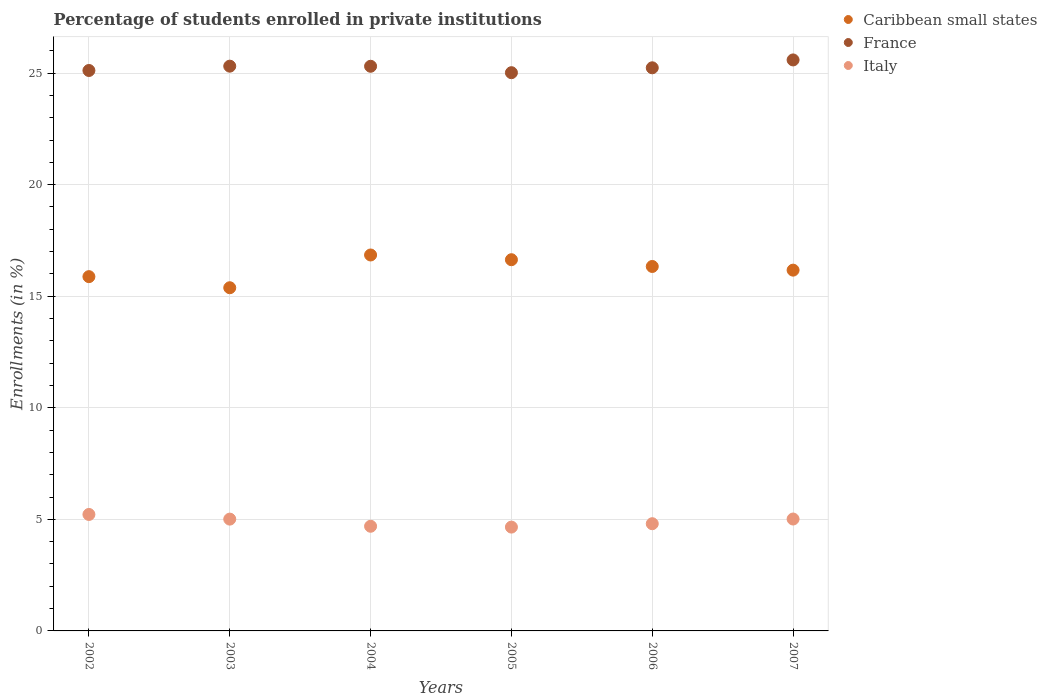Is the number of dotlines equal to the number of legend labels?
Make the answer very short. Yes. What is the percentage of trained teachers in France in 2006?
Provide a short and direct response. 25.24. Across all years, what is the maximum percentage of trained teachers in Italy?
Provide a succinct answer. 5.22. Across all years, what is the minimum percentage of trained teachers in Italy?
Offer a terse response. 4.65. In which year was the percentage of trained teachers in Caribbean small states minimum?
Keep it short and to the point. 2003. What is the total percentage of trained teachers in France in the graph?
Give a very brief answer. 151.57. What is the difference between the percentage of trained teachers in Caribbean small states in 2006 and that in 2007?
Keep it short and to the point. 0.16. What is the difference between the percentage of trained teachers in Italy in 2005 and the percentage of trained teachers in Caribbean small states in 2007?
Make the answer very short. -11.52. What is the average percentage of trained teachers in Italy per year?
Provide a succinct answer. 4.9. In the year 2005, what is the difference between the percentage of trained teachers in Caribbean small states and percentage of trained teachers in Italy?
Offer a very short reply. 11.98. What is the ratio of the percentage of trained teachers in Italy in 2003 to that in 2006?
Give a very brief answer. 1.04. Is the percentage of trained teachers in France in 2002 less than that in 2005?
Your answer should be compact. No. What is the difference between the highest and the second highest percentage of trained teachers in Italy?
Offer a terse response. 0.21. What is the difference between the highest and the lowest percentage of trained teachers in France?
Your answer should be very brief. 0.57. How many dotlines are there?
Offer a terse response. 3. Are the values on the major ticks of Y-axis written in scientific E-notation?
Give a very brief answer. No. Does the graph contain any zero values?
Give a very brief answer. No. How many legend labels are there?
Offer a terse response. 3. How are the legend labels stacked?
Provide a short and direct response. Vertical. What is the title of the graph?
Provide a succinct answer. Percentage of students enrolled in private institutions. Does "Libya" appear as one of the legend labels in the graph?
Provide a succinct answer. No. What is the label or title of the Y-axis?
Provide a short and direct response. Enrollments (in %). What is the Enrollments (in %) of Caribbean small states in 2002?
Provide a short and direct response. 15.88. What is the Enrollments (in %) in France in 2002?
Provide a succinct answer. 25.12. What is the Enrollments (in %) in Italy in 2002?
Offer a very short reply. 5.22. What is the Enrollments (in %) in Caribbean small states in 2003?
Keep it short and to the point. 15.38. What is the Enrollments (in %) of France in 2003?
Provide a short and direct response. 25.31. What is the Enrollments (in %) of Italy in 2003?
Your response must be concise. 5.01. What is the Enrollments (in %) in Caribbean small states in 2004?
Keep it short and to the point. 16.85. What is the Enrollments (in %) in France in 2004?
Offer a very short reply. 25.3. What is the Enrollments (in %) of Italy in 2004?
Provide a short and direct response. 4.69. What is the Enrollments (in %) in Caribbean small states in 2005?
Ensure brevity in your answer.  16.64. What is the Enrollments (in %) in France in 2005?
Your answer should be compact. 25.02. What is the Enrollments (in %) in Italy in 2005?
Make the answer very short. 4.65. What is the Enrollments (in %) of Caribbean small states in 2006?
Offer a very short reply. 16.33. What is the Enrollments (in %) of France in 2006?
Your answer should be very brief. 25.24. What is the Enrollments (in %) of Italy in 2006?
Your answer should be compact. 4.8. What is the Enrollments (in %) in Caribbean small states in 2007?
Offer a terse response. 16.17. What is the Enrollments (in %) in France in 2007?
Give a very brief answer. 25.59. What is the Enrollments (in %) of Italy in 2007?
Make the answer very short. 5.01. Across all years, what is the maximum Enrollments (in %) of Caribbean small states?
Your answer should be very brief. 16.85. Across all years, what is the maximum Enrollments (in %) in France?
Provide a succinct answer. 25.59. Across all years, what is the maximum Enrollments (in %) in Italy?
Offer a very short reply. 5.22. Across all years, what is the minimum Enrollments (in %) in Caribbean small states?
Offer a very short reply. 15.38. Across all years, what is the minimum Enrollments (in %) in France?
Keep it short and to the point. 25.02. Across all years, what is the minimum Enrollments (in %) in Italy?
Ensure brevity in your answer.  4.65. What is the total Enrollments (in %) in Caribbean small states in the graph?
Make the answer very short. 97.24. What is the total Enrollments (in %) of France in the graph?
Your response must be concise. 151.57. What is the total Enrollments (in %) of Italy in the graph?
Your response must be concise. 29.39. What is the difference between the Enrollments (in %) of Caribbean small states in 2002 and that in 2003?
Your answer should be compact. 0.5. What is the difference between the Enrollments (in %) in France in 2002 and that in 2003?
Your answer should be very brief. -0.19. What is the difference between the Enrollments (in %) of Italy in 2002 and that in 2003?
Offer a very short reply. 0.21. What is the difference between the Enrollments (in %) of Caribbean small states in 2002 and that in 2004?
Keep it short and to the point. -0.97. What is the difference between the Enrollments (in %) in France in 2002 and that in 2004?
Give a very brief answer. -0.19. What is the difference between the Enrollments (in %) in Italy in 2002 and that in 2004?
Keep it short and to the point. 0.53. What is the difference between the Enrollments (in %) in Caribbean small states in 2002 and that in 2005?
Offer a terse response. -0.76. What is the difference between the Enrollments (in %) of France in 2002 and that in 2005?
Your answer should be very brief. 0.1. What is the difference between the Enrollments (in %) of Italy in 2002 and that in 2005?
Provide a short and direct response. 0.57. What is the difference between the Enrollments (in %) in Caribbean small states in 2002 and that in 2006?
Ensure brevity in your answer.  -0.46. What is the difference between the Enrollments (in %) in France in 2002 and that in 2006?
Provide a short and direct response. -0.12. What is the difference between the Enrollments (in %) of Italy in 2002 and that in 2006?
Provide a short and direct response. 0.41. What is the difference between the Enrollments (in %) in Caribbean small states in 2002 and that in 2007?
Provide a succinct answer. -0.29. What is the difference between the Enrollments (in %) in France in 2002 and that in 2007?
Offer a terse response. -0.47. What is the difference between the Enrollments (in %) of Italy in 2002 and that in 2007?
Give a very brief answer. 0.21. What is the difference between the Enrollments (in %) in Caribbean small states in 2003 and that in 2004?
Ensure brevity in your answer.  -1.47. What is the difference between the Enrollments (in %) of France in 2003 and that in 2004?
Your answer should be compact. 0. What is the difference between the Enrollments (in %) of Italy in 2003 and that in 2004?
Offer a very short reply. 0.32. What is the difference between the Enrollments (in %) in Caribbean small states in 2003 and that in 2005?
Your answer should be very brief. -1.26. What is the difference between the Enrollments (in %) of France in 2003 and that in 2005?
Keep it short and to the point. 0.29. What is the difference between the Enrollments (in %) of Italy in 2003 and that in 2005?
Provide a succinct answer. 0.36. What is the difference between the Enrollments (in %) of Caribbean small states in 2003 and that in 2006?
Offer a terse response. -0.95. What is the difference between the Enrollments (in %) of France in 2003 and that in 2006?
Provide a short and direct response. 0.07. What is the difference between the Enrollments (in %) of Italy in 2003 and that in 2006?
Keep it short and to the point. 0.21. What is the difference between the Enrollments (in %) in Caribbean small states in 2003 and that in 2007?
Keep it short and to the point. -0.79. What is the difference between the Enrollments (in %) in France in 2003 and that in 2007?
Your answer should be very brief. -0.28. What is the difference between the Enrollments (in %) of Italy in 2003 and that in 2007?
Your answer should be very brief. -0. What is the difference between the Enrollments (in %) of Caribbean small states in 2004 and that in 2005?
Your answer should be compact. 0.21. What is the difference between the Enrollments (in %) of France in 2004 and that in 2005?
Provide a succinct answer. 0.29. What is the difference between the Enrollments (in %) in Italy in 2004 and that in 2005?
Offer a very short reply. 0.04. What is the difference between the Enrollments (in %) of Caribbean small states in 2004 and that in 2006?
Your answer should be very brief. 0.51. What is the difference between the Enrollments (in %) of France in 2004 and that in 2006?
Provide a short and direct response. 0.07. What is the difference between the Enrollments (in %) of Italy in 2004 and that in 2006?
Your answer should be very brief. -0.11. What is the difference between the Enrollments (in %) in Caribbean small states in 2004 and that in 2007?
Give a very brief answer. 0.68. What is the difference between the Enrollments (in %) in France in 2004 and that in 2007?
Offer a terse response. -0.28. What is the difference between the Enrollments (in %) in Italy in 2004 and that in 2007?
Make the answer very short. -0.32. What is the difference between the Enrollments (in %) in Caribbean small states in 2005 and that in 2006?
Offer a very short reply. 0.3. What is the difference between the Enrollments (in %) in France in 2005 and that in 2006?
Your answer should be very brief. -0.22. What is the difference between the Enrollments (in %) in Italy in 2005 and that in 2006?
Provide a succinct answer. -0.15. What is the difference between the Enrollments (in %) in Caribbean small states in 2005 and that in 2007?
Your answer should be compact. 0.47. What is the difference between the Enrollments (in %) of France in 2005 and that in 2007?
Make the answer very short. -0.57. What is the difference between the Enrollments (in %) in Italy in 2005 and that in 2007?
Provide a succinct answer. -0.36. What is the difference between the Enrollments (in %) in Caribbean small states in 2006 and that in 2007?
Ensure brevity in your answer.  0.16. What is the difference between the Enrollments (in %) in France in 2006 and that in 2007?
Ensure brevity in your answer.  -0.35. What is the difference between the Enrollments (in %) of Italy in 2006 and that in 2007?
Your answer should be compact. -0.21. What is the difference between the Enrollments (in %) in Caribbean small states in 2002 and the Enrollments (in %) in France in 2003?
Make the answer very short. -9.43. What is the difference between the Enrollments (in %) of Caribbean small states in 2002 and the Enrollments (in %) of Italy in 2003?
Provide a succinct answer. 10.87. What is the difference between the Enrollments (in %) in France in 2002 and the Enrollments (in %) in Italy in 2003?
Keep it short and to the point. 20.11. What is the difference between the Enrollments (in %) of Caribbean small states in 2002 and the Enrollments (in %) of France in 2004?
Your answer should be compact. -9.43. What is the difference between the Enrollments (in %) in Caribbean small states in 2002 and the Enrollments (in %) in Italy in 2004?
Your response must be concise. 11.19. What is the difference between the Enrollments (in %) of France in 2002 and the Enrollments (in %) of Italy in 2004?
Your response must be concise. 20.43. What is the difference between the Enrollments (in %) in Caribbean small states in 2002 and the Enrollments (in %) in France in 2005?
Your answer should be compact. -9.14. What is the difference between the Enrollments (in %) of Caribbean small states in 2002 and the Enrollments (in %) of Italy in 2005?
Offer a terse response. 11.22. What is the difference between the Enrollments (in %) in France in 2002 and the Enrollments (in %) in Italy in 2005?
Your answer should be very brief. 20.46. What is the difference between the Enrollments (in %) of Caribbean small states in 2002 and the Enrollments (in %) of France in 2006?
Offer a terse response. -9.36. What is the difference between the Enrollments (in %) in Caribbean small states in 2002 and the Enrollments (in %) in Italy in 2006?
Provide a succinct answer. 11.07. What is the difference between the Enrollments (in %) in France in 2002 and the Enrollments (in %) in Italy in 2006?
Provide a short and direct response. 20.31. What is the difference between the Enrollments (in %) in Caribbean small states in 2002 and the Enrollments (in %) in France in 2007?
Make the answer very short. -9.71. What is the difference between the Enrollments (in %) of Caribbean small states in 2002 and the Enrollments (in %) of Italy in 2007?
Provide a succinct answer. 10.86. What is the difference between the Enrollments (in %) of France in 2002 and the Enrollments (in %) of Italy in 2007?
Ensure brevity in your answer.  20.1. What is the difference between the Enrollments (in %) of Caribbean small states in 2003 and the Enrollments (in %) of France in 2004?
Keep it short and to the point. -9.92. What is the difference between the Enrollments (in %) of Caribbean small states in 2003 and the Enrollments (in %) of Italy in 2004?
Offer a terse response. 10.69. What is the difference between the Enrollments (in %) of France in 2003 and the Enrollments (in %) of Italy in 2004?
Your response must be concise. 20.62. What is the difference between the Enrollments (in %) of Caribbean small states in 2003 and the Enrollments (in %) of France in 2005?
Offer a terse response. -9.64. What is the difference between the Enrollments (in %) in Caribbean small states in 2003 and the Enrollments (in %) in Italy in 2005?
Keep it short and to the point. 10.73. What is the difference between the Enrollments (in %) in France in 2003 and the Enrollments (in %) in Italy in 2005?
Offer a terse response. 20.66. What is the difference between the Enrollments (in %) of Caribbean small states in 2003 and the Enrollments (in %) of France in 2006?
Offer a very short reply. -9.86. What is the difference between the Enrollments (in %) of Caribbean small states in 2003 and the Enrollments (in %) of Italy in 2006?
Provide a succinct answer. 10.57. What is the difference between the Enrollments (in %) of France in 2003 and the Enrollments (in %) of Italy in 2006?
Your answer should be very brief. 20.5. What is the difference between the Enrollments (in %) in Caribbean small states in 2003 and the Enrollments (in %) in France in 2007?
Give a very brief answer. -10.21. What is the difference between the Enrollments (in %) of Caribbean small states in 2003 and the Enrollments (in %) of Italy in 2007?
Your answer should be very brief. 10.37. What is the difference between the Enrollments (in %) in France in 2003 and the Enrollments (in %) in Italy in 2007?
Your answer should be very brief. 20.29. What is the difference between the Enrollments (in %) in Caribbean small states in 2004 and the Enrollments (in %) in France in 2005?
Make the answer very short. -8.17. What is the difference between the Enrollments (in %) in Caribbean small states in 2004 and the Enrollments (in %) in Italy in 2005?
Your answer should be very brief. 12.19. What is the difference between the Enrollments (in %) in France in 2004 and the Enrollments (in %) in Italy in 2005?
Give a very brief answer. 20.65. What is the difference between the Enrollments (in %) in Caribbean small states in 2004 and the Enrollments (in %) in France in 2006?
Make the answer very short. -8.39. What is the difference between the Enrollments (in %) of Caribbean small states in 2004 and the Enrollments (in %) of Italy in 2006?
Offer a very short reply. 12.04. What is the difference between the Enrollments (in %) of France in 2004 and the Enrollments (in %) of Italy in 2006?
Give a very brief answer. 20.5. What is the difference between the Enrollments (in %) in Caribbean small states in 2004 and the Enrollments (in %) in France in 2007?
Keep it short and to the point. -8.74. What is the difference between the Enrollments (in %) of Caribbean small states in 2004 and the Enrollments (in %) of Italy in 2007?
Give a very brief answer. 11.83. What is the difference between the Enrollments (in %) of France in 2004 and the Enrollments (in %) of Italy in 2007?
Give a very brief answer. 20.29. What is the difference between the Enrollments (in %) in Caribbean small states in 2005 and the Enrollments (in %) in France in 2006?
Your response must be concise. -8.6. What is the difference between the Enrollments (in %) in Caribbean small states in 2005 and the Enrollments (in %) in Italy in 2006?
Offer a very short reply. 11.83. What is the difference between the Enrollments (in %) in France in 2005 and the Enrollments (in %) in Italy in 2006?
Offer a terse response. 20.21. What is the difference between the Enrollments (in %) in Caribbean small states in 2005 and the Enrollments (in %) in France in 2007?
Your answer should be compact. -8.95. What is the difference between the Enrollments (in %) in Caribbean small states in 2005 and the Enrollments (in %) in Italy in 2007?
Provide a short and direct response. 11.62. What is the difference between the Enrollments (in %) of France in 2005 and the Enrollments (in %) of Italy in 2007?
Ensure brevity in your answer.  20. What is the difference between the Enrollments (in %) in Caribbean small states in 2006 and the Enrollments (in %) in France in 2007?
Provide a short and direct response. -9.26. What is the difference between the Enrollments (in %) of Caribbean small states in 2006 and the Enrollments (in %) of Italy in 2007?
Offer a very short reply. 11.32. What is the difference between the Enrollments (in %) of France in 2006 and the Enrollments (in %) of Italy in 2007?
Your response must be concise. 20.22. What is the average Enrollments (in %) of Caribbean small states per year?
Provide a succinct answer. 16.21. What is the average Enrollments (in %) in France per year?
Give a very brief answer. 25.26. What is the average Enrollments (in %) in Italy per year?
Your response must be concise. 4.9. In the year 2002, what is the difference between the Enrollments (in %) of Caribbean small states and Enrollments (in %) of France?
Offer a very short reply. -9.24. In the year 2002, what is the difference between the Enrollments (in %) in Caribbean small states and Enrollments (in %) in Italy?
Your answer should be very brief. 10.66. In the year 2002, what is the difference between the Enrollments (in %) in France and Enrollments (in %) in Italy?
Keep it short and to the point. 19.9. In the year 2003, what is the difference between the Enrollments (in %) in Caribbean small states and Enrollments (in %) in France?
Offer a terse response. -9.93. In the year 2003, what is the difference between the Enrollments (in %) in Caribbean small states and Enrollments (in %) in Italy?
Provide a short and direct response. 10.37. In the year 2003, what is the difference between the Enrollments (in %) in France and Enrollments (in %) in Italy?
Make the answer very short. 20.3. In the year 2004, what is the difference between the Enrollments (in %) of Caribbean small states and Enrollments (in %) of France?
Provide a succinct answer. -8.46. In the year 2004, what is the difference between the Enrollments (in %) in Caribbean small states and Enrollments (in %) in Italy?
Your answer should be very brief. 12.16. In the year 2004, what is the difference between the Enrollments (in %) in France and Enrollments (in %) in Italy?
Provide a short and direct response. 20.61. In the year 2005, what is the difference between the Enrollments (in %) in Caribbean small states and Enrollments (in %) in France?
Make the answer very short. -8.38. In the year 2005, what is the difference between the Enrollments (in %) of Caribbean small states and Enrollments (in %) of Italy?
Your response must be concise. 11.98. In the year 2005, what is the difference between the Enrollments (in %) of France and Enrollments (in %) of Italy?
Provide a short and direct response. 20.36. In the year 2006, what is the difference between the Enrollments (in %) in Caribbean small states and Enrollments (in %) in France?
Offer a very short reply. -8.9. In the year 2006, what is the difference between the Enrollments (in %) of Caribbean small states and Enrollments (in %) of Italy?
Offer a very short reply. 11.53. In the year 2006, what is the difference between the Enrollments (in %) of France and Enrollments (in %) of Italy?
Your answer should be compact. 20.43. In the year 2007, what is the difference between the Enrollments (in %) in Caribbean small states and Enrollments (in %) in France?
Provide a short and direct response. -9.42. In the year 2007, what is the difference between the Enrollments (in %) of Caribbean small states and Enrollments (in %) of Italy?
Your response must be concise. 11.15. In the year 2007, what is the difference between the Enrollments (in %) of France and Enrollments (in %) of Italy?
Offer a very short reply. 20.57. What is the ratio of the Enrollments (in %) of Caribbean small states in 2002 to that in 2003?
Keep it short and to the point. 1.03. What is the ratio of the Enrollments (in %) of France in 2002 to that in 2003?
Ensure brevity in your answer.  0.99. What is the ratio of the Enrollments (in %) in Italy in 2002 to that in 2003?
Provide a succinct answer. 1.04. What is the ratio of the Enrollments (in %) of Caribbean small states in 2002 to that in 2004?
Offer a terse response. 0.94. What is the ratio of the Enrollments (in %) of Italy in 2002 to that in 2004?
Ensure brevity in your answer.  1.11. What is the ratio of the Enrollments (in %) of Caribbean small states in 2002 to that in 2005?
Provide a succinct answer. 0.95. What is the ratio of the Enrollments (in %) in France in 2002 to that in 2005?
Your response must be concise. 1. What is the ratio of the Enrollments (in %) in Italy in 2002 to that in 2005?
Make the answer very short. 1.12. What is the ratio of the Enrollments (in %) of Caribbean small states in 2002 to that in 2006?
Give a very brief answer. 0.97. What is the ratio of the Enrollments (in %) of France in 2002 to that in 2006?
Make the answer very short. 1. What is the ratio of the Enrollments (in %) of Italy in 2002 to that in 2006?
Offer a terse response. 1.09. What is the ratio of the Enrollments (in %) of Caribbean small states in 2002 to that in 2007?
Ensure brevity in your answer.  0.98. What is the ratio of the Enrollments (in %) of France in 2002 to that in 2007?
Provide a succinct answer. 0.98. What is the ratio of the Enrollments (in %) of Italy in 2002 to that in 2007?
Provide a succinct answer. 1.04. What is the ratio of the Enrollments (in %) in Caribbean small states in 2003 to that in 2004?
Your answer should be very brief. 0.91. What is the ratio of the Enrollments (in %) in France in 2003 to that in 2004?
Give a very brief answer. 1. What is the ratio of the Enrollments (in %) of Italy in 2003 to that in 2004?
Provide a succinct answer. 1.07. What is the ratio of the Enrollments (in %) of Caribbean small states in 2003 to that in 2005?
Provide a succinct answer. 0.92. What is the ratio of the Enrollments (in %) of France in 2003 to that in 2005?
Provide a succinct answer. 1.01. What is the ratio of the Enrollments (in %) of Italy in 2003 to that in 2005?
Provide a succinct answer. 1.08. What is the ratio of the Enrollments (in %) of Caribbean small states in 2003 to that in 2006?
Offer a very short reply. 0.94. What is the ratio of the Enrollments (in %) of France in 2003 to that in 2006?
Provide a short and direct response. 1. What is the ratio of the Enrollments (in %) in Italy in 2003 to that in 2006?
Give a very brief answer. 1.04. What is the ratio of the Enrollments (in %) in Caribbean small states in 2003 to that in 2007?
Your answer should be compact. 0.95. What is the ratio of the Enrollments (in %) in Italy in 2003 to that in 2007?
Ensure brevity in your answer.  1. What is the ratio of the Enrollments (in %) of Caribbean small states in 2004 to that in 2005?
Offer a terse response. 1.01. What is the ratio of the Enrollments (in %) of France in 2004 to that in 2005?
Offer a very short reply. 1.01. What is the ratio of the Enrollments (in %) of Caribbean small states in 2004 to that in 2006?
Provide a short and direct response. 1.03. What is the ratio of the Enrollments (in %) of Italy in 2004 to that in 2006?
Your answer should be very brief. 0.98. What is the ratio of the Enrollments (in %) in Caribbean small states in 2004 to that in 2007?
Provide a short and direct response. 1.04. What is the ratio of the Enrollments (in %) in France in 2004 to that in 2007?
Give a very brief answer. 0.99. What is the ratio of the Enrollments (in %) in Italy in 2004 to that in 2007?
Ensure brevity in your answer.  0.94. What is the ratio of the Enrollments (in %) of Caribbean small states in 2005 to that in 2006?
Your answer should be compact. 1.02. What is the ratio of the Enrollments (in %) of France in 2005 to that in 2006?
Make the answer very short. 0.99. What is the ratio of the Enrollments (in %) of Italy in 2005 to that in 2006?
Give a very brief answer. 0.97. What is the ratio of the Enrollments (in %) in Caribbean small states in 2005 to that in 2007?
Your answer should be compact. 1.03. What is the ratio of the Enrollments (in %) in France in 2005 to that in 2007?
Keep it short and to the point. 0.98. What is the ratio of the Enrollments (in %) in Italy in 2005 to that in 2007?
Give a very brief answer. 0.93. What is the ratio of the Enrollments (in %) in Caribbean small states in 2006 to that in 2007?
Ensure brevity in your answer.  1.01. What is the ratio of the Enrollments (in %) in France in 2006 to that in 2007?
Offer a very short reply. 0.99. What is the ratio of the Enrollments (in %) of Italy in 2006 to that in 2007?
Your answer should be compact. 0.96. What is the difference between the highest and the second highest Enrollments (in %) in Caribbean small states?
Make the answer very short. 0.21. What is the difference between the highest and the second highest Enrollments (in %) in France?
Ensure brevity in your answer.  0.28. What is the difference between the highest and the second highest Enrollments (in %) of Italy?
Ensure brevity in your answer.  0.21. What is the difference between the highest and the lowest Enrollments (in %) in Caribbean small states?
Your answer should be compact. 1.47. What is the difference between the highest and the lowest Enrollments (in %) in France?
Offer a terse response. 0.57. What is the difference between the highest and the lowest Enrollments (in %) in Italy?
Provide a succinct answer. 0.57. 